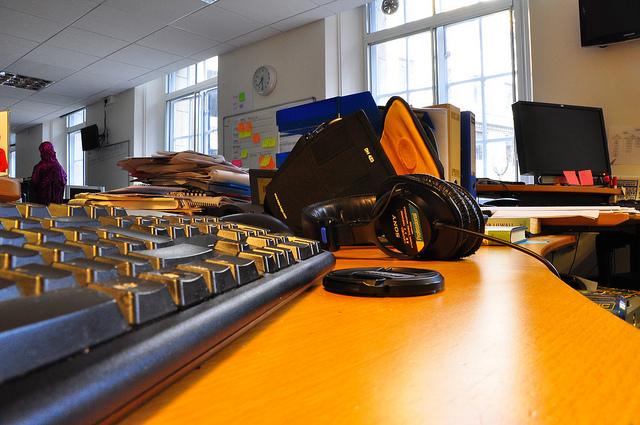Is there a computer mouse in this photo?
Short answer required. Yes. Is there anyone in the room?
Write a very short answer. Yes. Would it be a good idea to eat chips here?
Write a very short answer. No. 